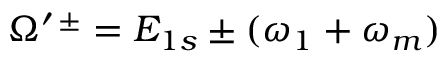<formula> <loc_0><loc_0><loc_500><loc_500>\Omega ^ { \prime \, \pm } = E _ { 1 s } \pm ( \omega _ { 1 } + \omega _ { m } )</formula> 